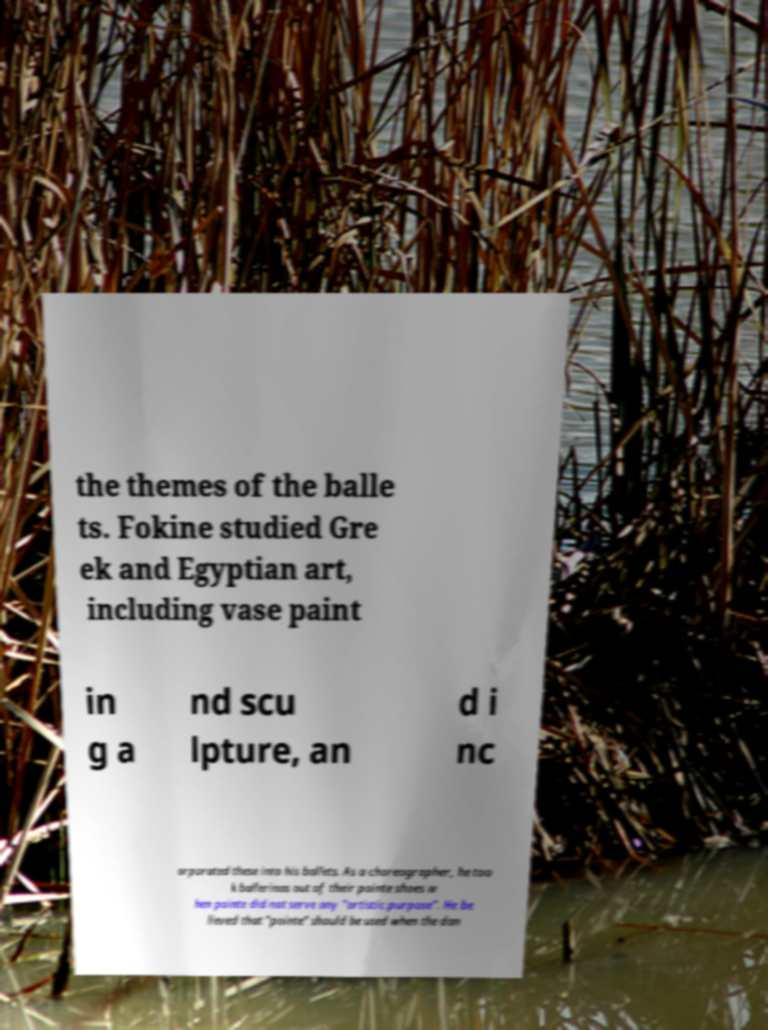Please read and relay the text visible in this image. What does it say? the themes of the balle ts. Fokine studied Gre ek and Egyptian art, including vase paint in g a nd scu lpture, an d i nc orporated these into his ballets. As a choreographer, he too k ballerinas out of their pointe shoes w hen pointe did not serve any "artistic purpose". He be lieved that "pointe" should be used when the dan 